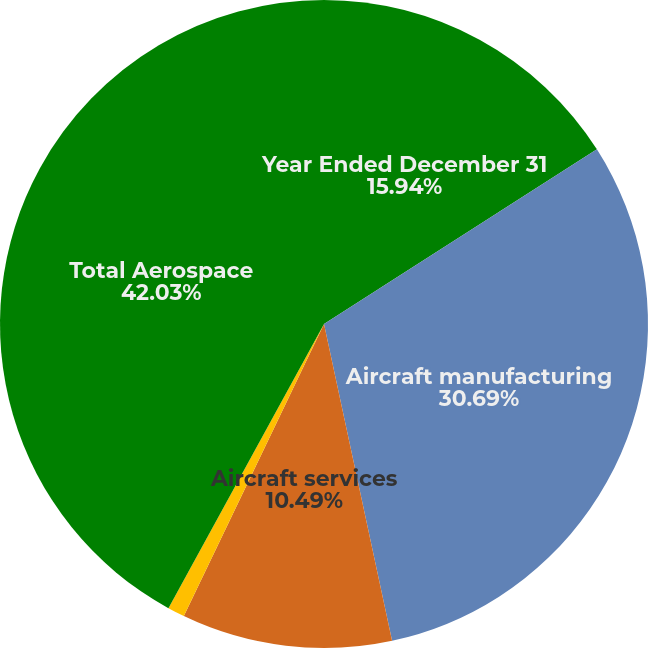Convert chart. <chart><loc_0><loc_0><loc_500><loc_500><pie_chart><fcel>Year Ended December 31<fcel>Aircraft manufacturing<fcel>Aircraft services<fcel>Pre-owned aircraft<fcel>Total Aerospace<nl><fcel>15.94%<fcel>30.69%<fcel>10.49%<fcel>0.85%<fcel>42.03%<nl></chart> 